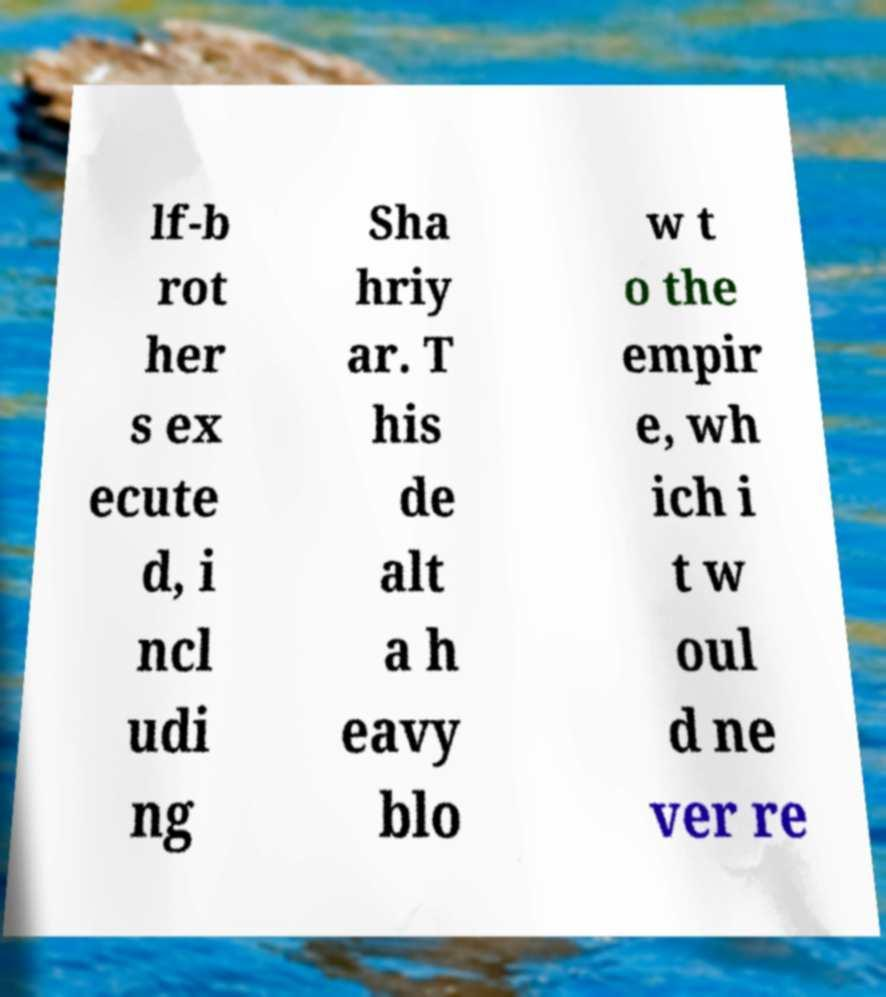There's text embedded in this image that I need extracted. Can you transcribe it verbatim? lf-b rot her s ex ecute d, i ncl udi ng Sha hriy ar. T his de alt a h eavy blo w t o the empir e, wh ich i t w oul d ne ver re 